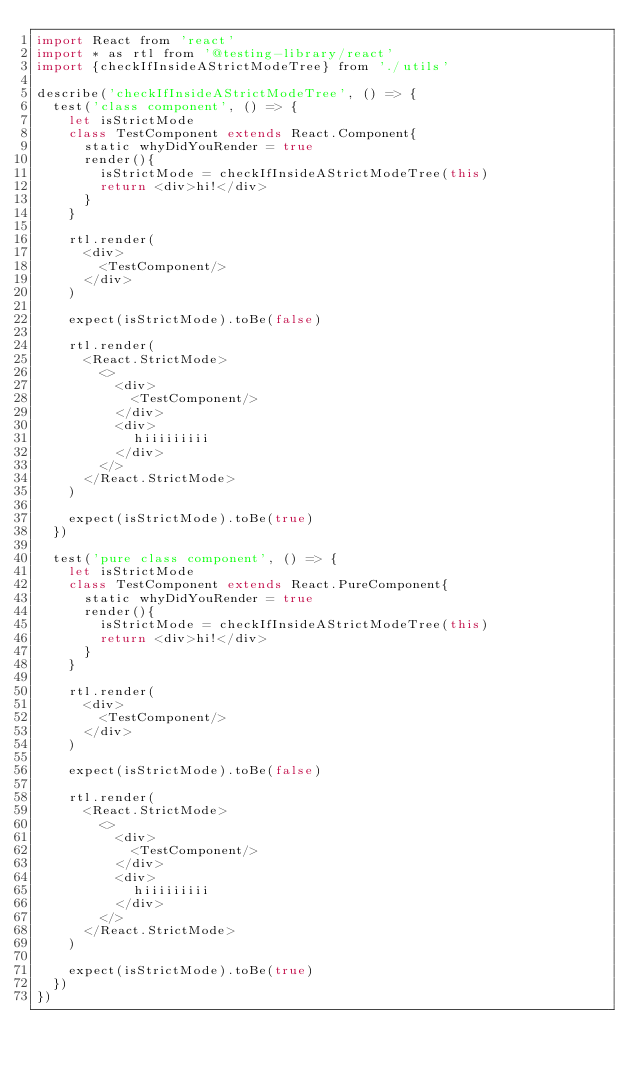<code> <loc_0><loc_0><loc_500><loc_500><_JavaScript_>import React from 'react'
import * as rtl from '@testing-library/react'
import {checkIfInsideAStrictModeTree} from './utils'

describe('checkIfInsideAStrictModeTree', () => {
  test('class component', () => {
    let isStrictMode
    class TestComponent extends React.Component{
      static whyDidYouRender = true
      render(){
        isStrictMode = checkIfInsideAStrictModeTree(this)
        return <div>hi!</div>
      }
    }

    rtl.render(
      <div>
        <TestComponent/>
      </div>
    )

    expect(isStrictMode).toBe(false)

    rtl.render(
      <React.StrictMode>
        <>
          <div>
            <TestComponent/>
          </div>
          <div>
            hiiiiiiiii
          </div>
        </>
      </React.StrictMode>
    )

    expect(isStrictMode).toBe(true)
  })

  test('pure class component', () => {
    let isStrictMode
    class TestComponent extends React.PureComponent{
      static whyDidYouRender = true
      render(){
        isStrictMode = checkIfInsideAStrictModeTree(this)
        return <div>hi!</div>
      }
    }

    rtl.render(
      <div>
        <TestComponent/>
      </div>
    )

    expect(isStrictMode).toBe(false)

    rtl.render(
      <React.StrictMode>
        <>
          <div>
            <TestComponent/>
          </div>
          <div>
            hiiiiiiiii
          </div>
        </>
      </React.StrictMode>
    )

    expect(isStrictMode).toBe(true)
  })
})
</code> 